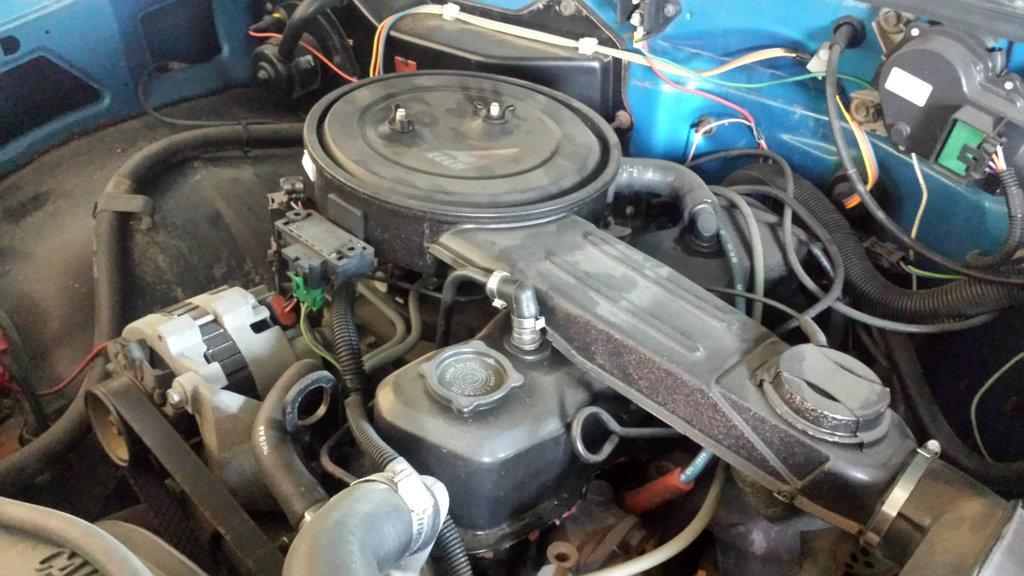What is the main object in the image? There is an engine in the image. Are there any other elements present in the image besides the engine? Yes, there are wires in the image. Can you see a turkey interacting with the engine in the image? No, there is no turkey present in the image. What type of horn is attached to the engine in the image? There is no horn attached to the engine in the image. 